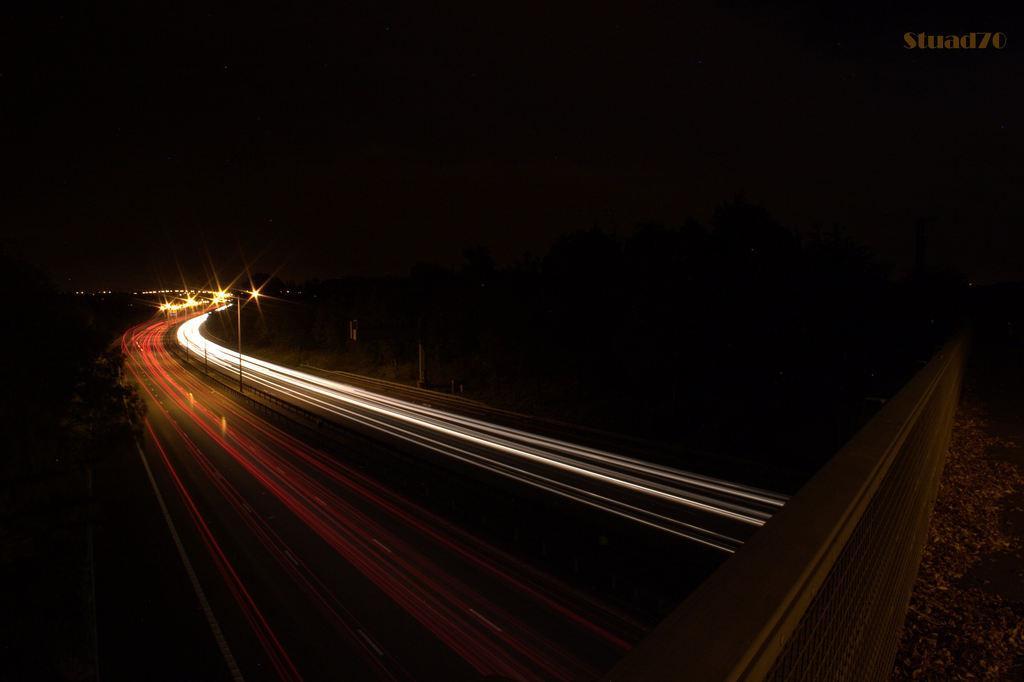How would you summarize this image in a sentence or two? In this image I can see the dark picture in which I can see the road, a bridge, few trees and few lights on the road. In the background I can see the dark sky. 